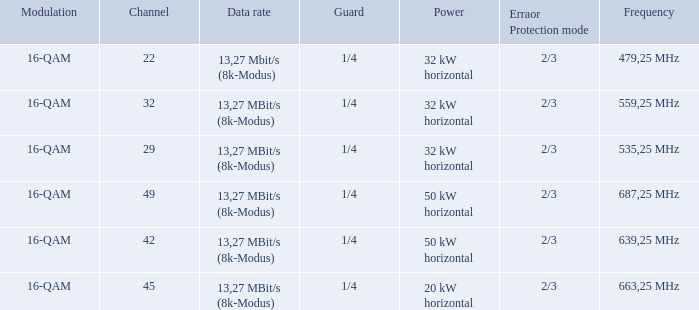Can you give me this table as a dict? {'header': ['Modulation', 'Channel', 'Data rate', 'Guard', 'Power', 'Erraor Protection mode', 'Frequency'], 'rows': [['16-QAM', '22', '13,27 Mbit/s (8k-Modus)', '1/4', '32 kW horizontal', '2/3', '479,25 MHz'], ['16-QAM', '32', '13,27 MBit/s (8k-Modus)', '1/4', '32 kW horizontal', '2/3', '559,25 MHz'], ['16-QAM', '29', '13,27 MBit/s (8k-Modus)', '1/4', '32 kW horizontal', '2/3', '535,25 MHz'], ['16-QAM', '49', '13,27 MBit/s (8k-Modus)', '1/4', '50 kW horizontal', '2/3', '687,25 MHz'], ['16-QAM', '42', '13,27 MBit/s (8k-Modus)', '1/4', '50 kW horizontal', '2/3', '639,25 MHz'], ['16-QAM', '45', '13,27 MBit/s (8k-Modus)', '1/4', '20 kW horizontal', '2/3', '663,25 MHz']]} On channel 32, when the power is 32 kw in the horizontal direction, what is the modulation? 16-QAM. 